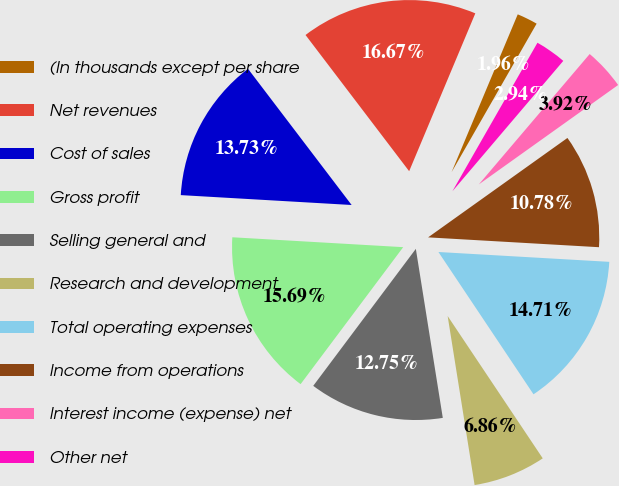Convert chart to OTSL. <chart><loc_0><loc_0><loc_500><loc_500><pie_chart><fcel>(In thousands except per share<fcel>Net revenues<fcel>Cost of sales<fcel>Gross profit<fcel>Selling general and<fcel>Research and development<fcel>Total operating expenses<fcel>Income from operations<fcel>Interest income (expense) net<fcel>Other net<nl><fcel>1.96%<fcel>16.67%<fcel>13.73%<fcel>15.69%<fcel>12.75%<fcel>6.86%<fcel>14.71%<fcel>10.78%<fcel>3.92%<fcel>2.94%<nl></chart> 